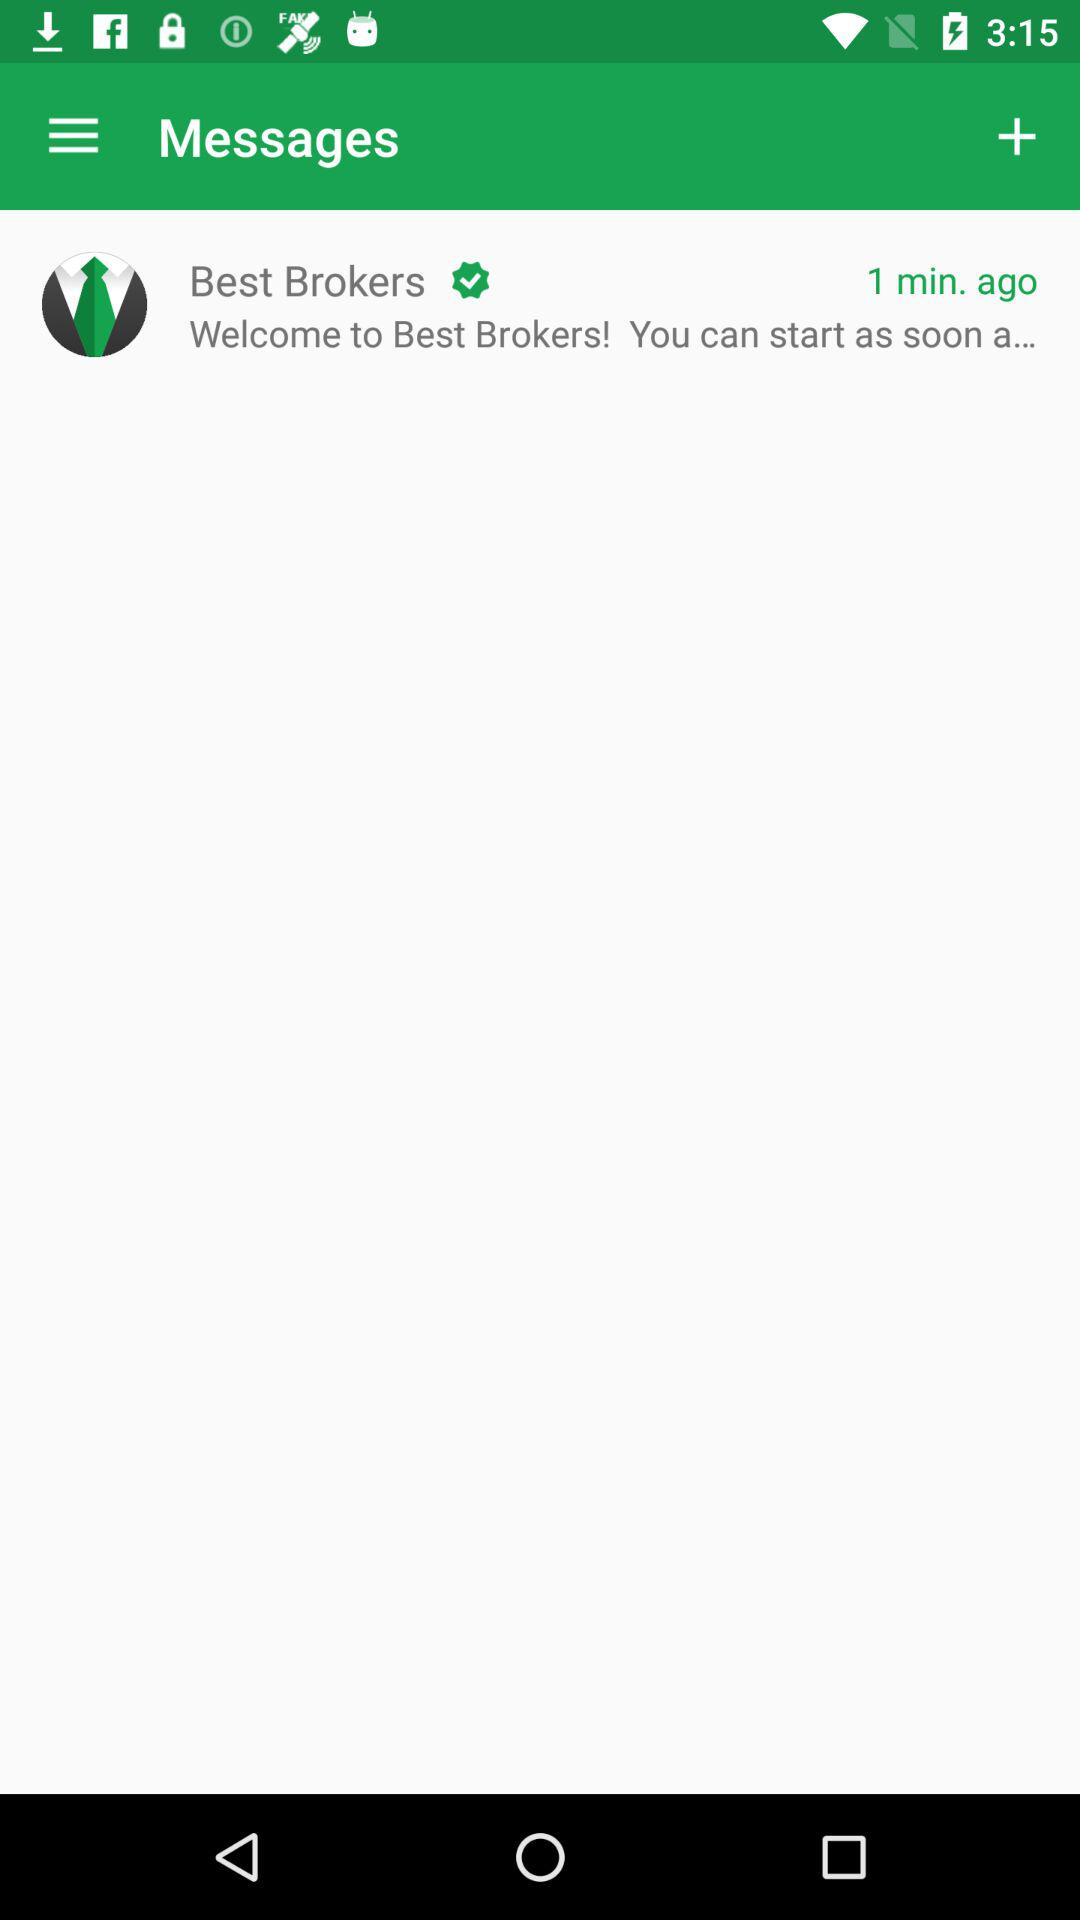Where did the last message come from? The last message came from "Best Brokers". 